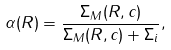Convert formula to latex. <formula><loc_0><loc_0><loc_500><loc_500>\alpha ( R ) = \frac { \Sigma _ { M } ( R , c ) } { \Sigma _ { M } ( R , c ) + \Sigma _ { i } } ,</formula> 